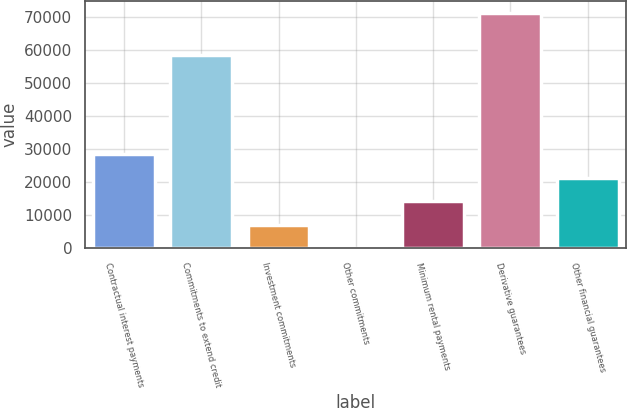<chart> <loc_0><loc_0><loc_500><loc_500><bar_chart><fcel>Contractual interest payments<fcel>Commitments to extend credit<fcel>Investment commitments<fcel>Other commitments<fcel>Minimum rental payments<fcel>Derivative guarantees<fcel>Other financial guarantees<nl><fcel>28514.6<fcel>58412<fcel>7139.9<fcel>15<fcel>14264.8<fcel>71264<fcel>21389.7<nl></chart> 